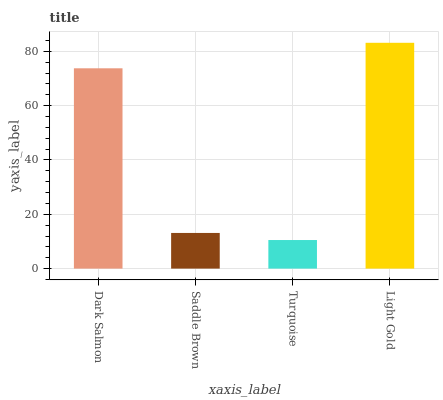Is Turquoise the minimum?
Answer yes or no. Yes. Is Light Gold the maximum?
Answer yes or no. Yes. Is Saddle Brown the minimum?
Answer yes or no. No. Is Saddle Brown the maximum?
Answer yes or no. No. Is Dark Salmon greater than Saddle Brown?
Answer yes or no. Yes. Is Saddle Brown less than Dark Salmon?
Answer yes or no. Yes. Is Saddle Brown greater than Dark Salmon?
Answer yes or no. No. Is Dark Salmon less than Saddle Brown?
Answer yes or no. No. Is Dark Salmon the high median?
Answer yes or no. Yes. Is Saddle Brown the low median?
Answer yes or no. Yes. Is Saddle Brown the high median?
Answer yes or no. No. Is Dark Salmon the low median?
Answer yes or no. No. 